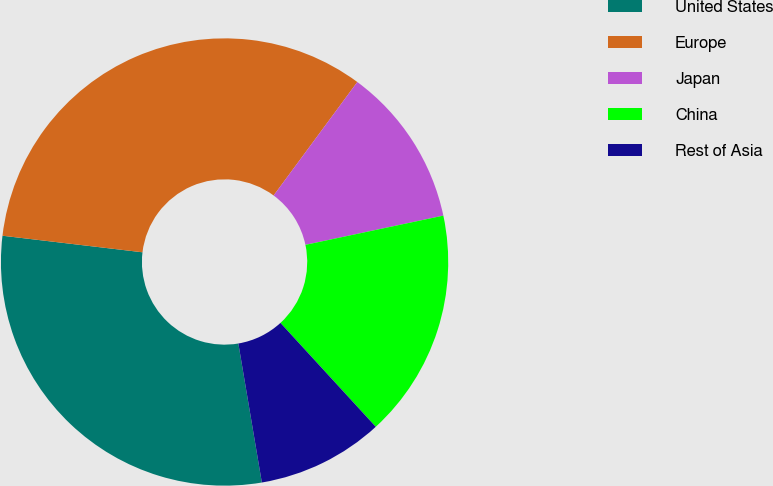Convert chart. <chart><loc_0><loc_0><loc_500><loc_500><pie_chart><fcel>United States<fcel>Europe<fcel>Japan<fcel>China<fcel>Rest of Asia<nl><fcel>29.54%<fcel>33.24%<fcel>11.56%<fcel>16.51%<fcel>9.15%<nl></chart> 